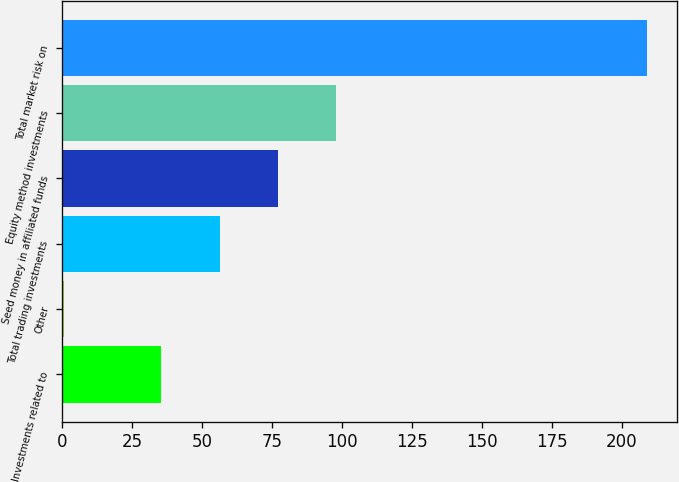<chart> <loc_0><loc_0><loc_500><loc_500><bar_chart><fcel>Investments related to<fcel>Other<fcel>Total trading investments<fcel>Seed money in affiliated funds<fcel>Equity method investments<fcel>Total market risk on<nl><fcel>35.5<fcel>0.7<fcel>56.34<fcel>77.18<fcel>98.02<fcel>209.1<nl></chart> 